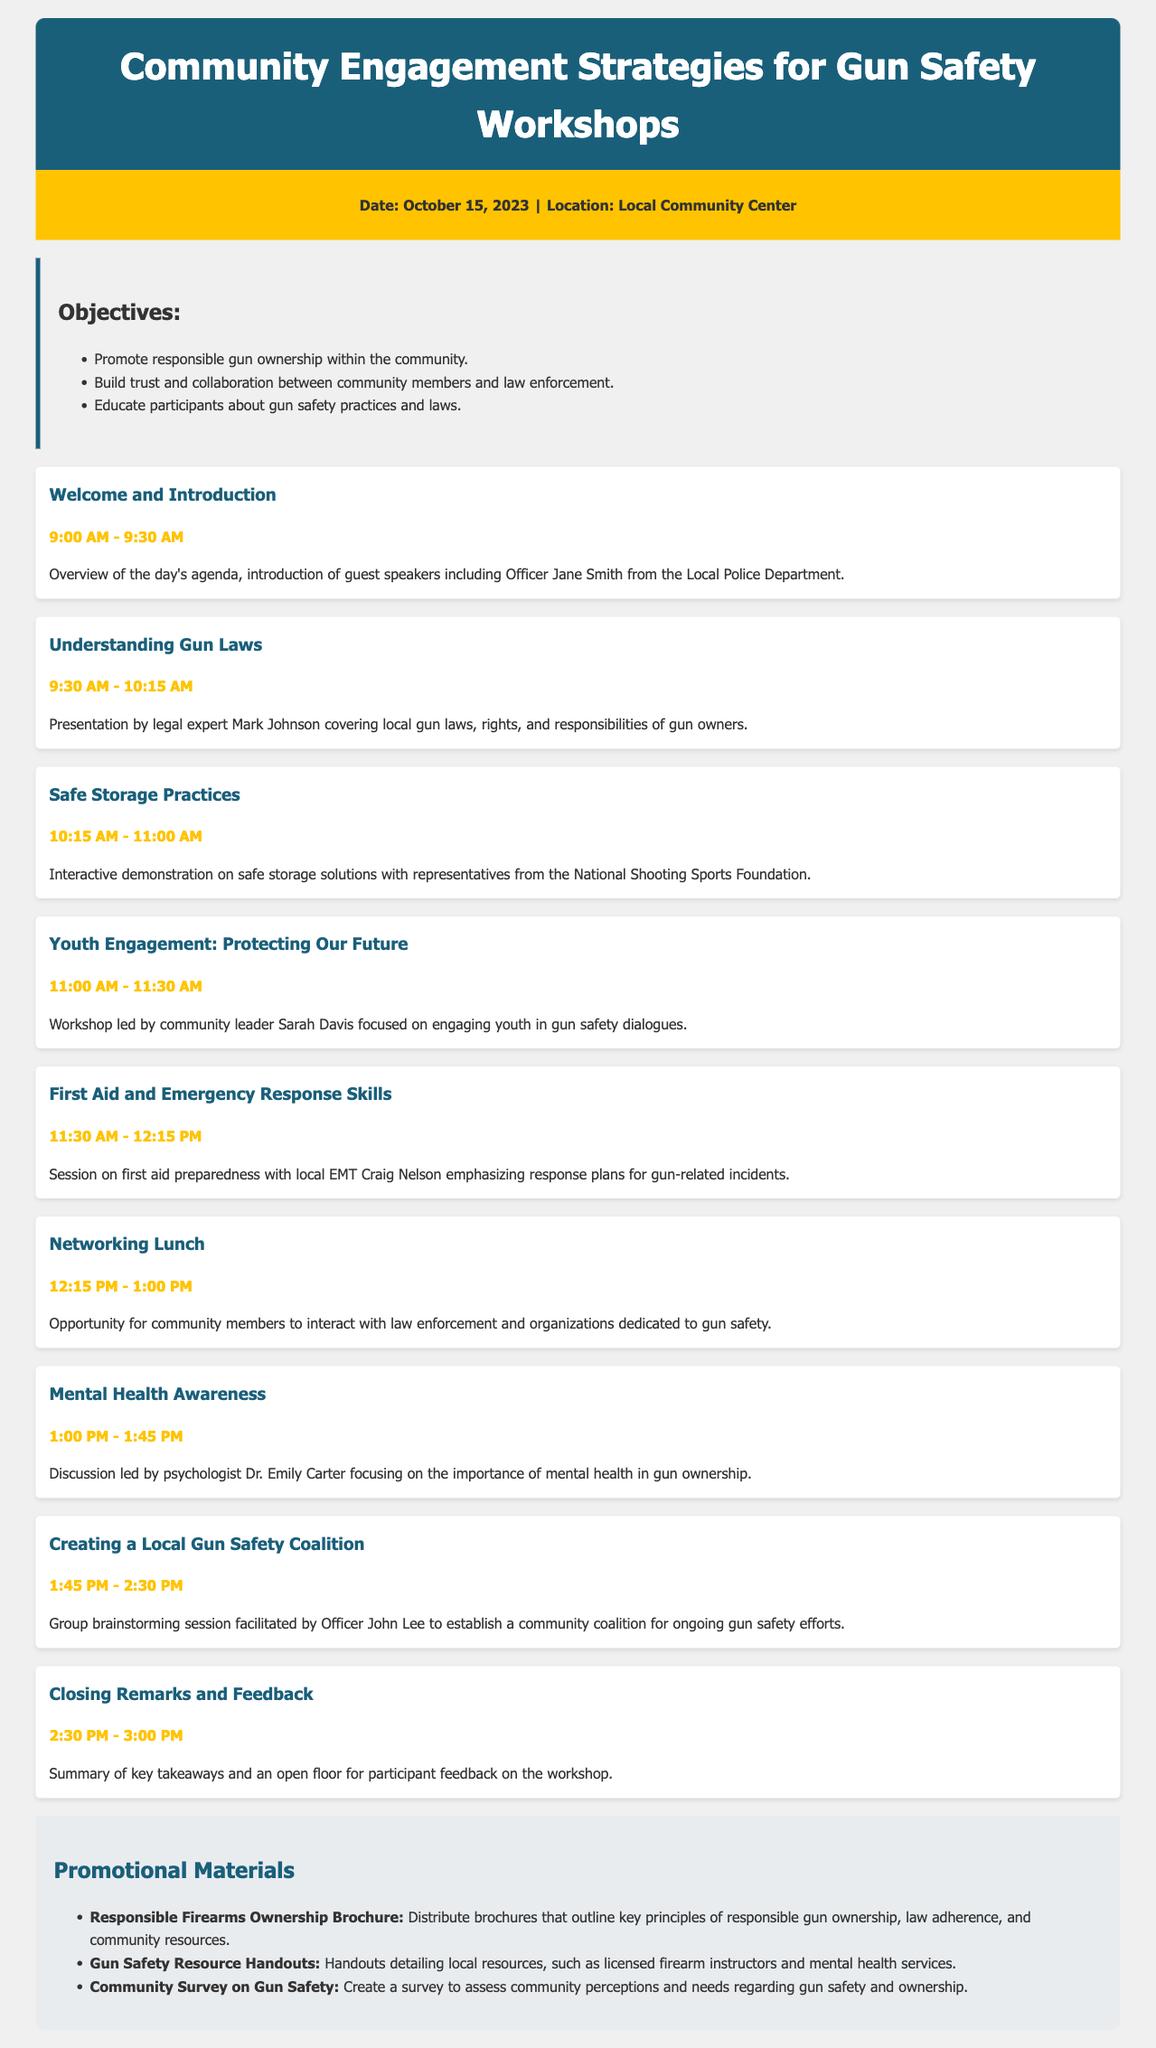what is the date of the workshop? The date of the workshop is explicitly stated in the document as October 15, 2023.
Answer: October 15, 2023 who is leading the workshop on youth engagement? The document names community leader Sarah Davis as the person leading the youth engagement workshop.
Answer: Sarah Davis what time does the first aid session start? The starting time for the first aid session can be found in the agenda as 11:30 AM.
Answer: 11:30 AM how many objectives are listed in the document? The document enumerates three objectives, which are clearly stated in the objectives section.
Answer: 3 what is the main focus of the Mental Health Awareness discussion? The focus of the discussion is indicated as the importance of mental health in gun ownership.
Answer: Importance of mental health in gun ownership who will provide closing remarks? The agenda indicates that closing remarks will be provided after the summary, with no specific person's name given.
Answer: Not specified what is the purpose of the community survey on gun safety? The document states that the purpose of the community survey is to assess perceptions and needs regarding gun safety and ownership.
Answer: Assess community perceptions and needs regarding gun safety what type of materials will be distributed at the workshop? The document outlines the types of promotional materials to be distributed, such as brochures and handouts.
Answer: Brochures and handouts what is the final item in the agenda? The final item mentioned in the agenda is closing remarks and feedback session.
Answer: Closing Remarks and Feedback 